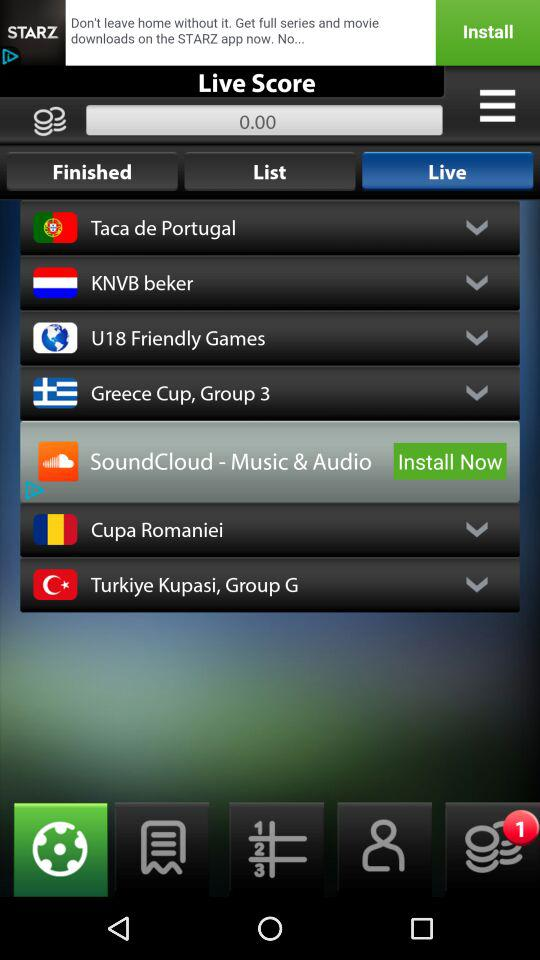How many unread notifications are shown on the screen?
When the provided information is insufficient, respond with <no answer>. <no answer> 